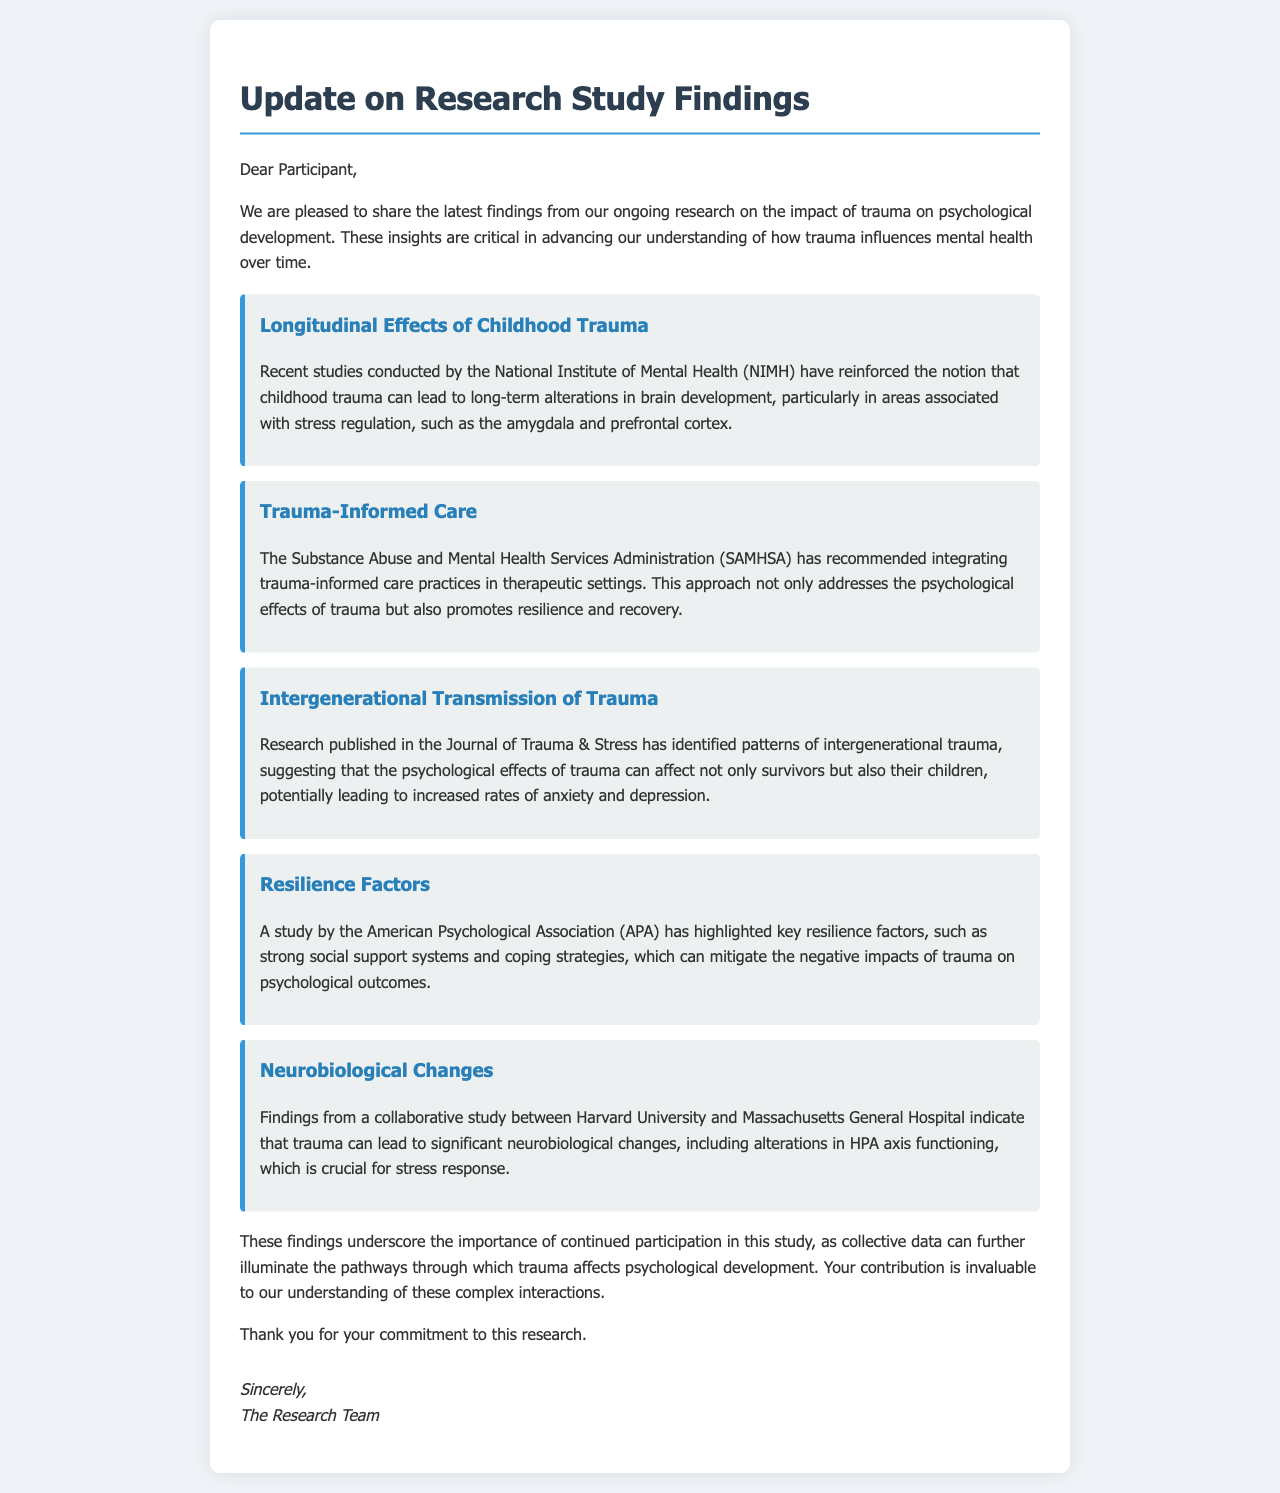What is the focus of the recent studies conducted by NIMH? The focus is on the long-term alterations in brain development due to childhood trauma.
Answer: Long-term alterations in brain development What organization recommends trauma-informed care practices? The document mentions a specific organization that supports this approach in therapeutic settings.
Answer: SAMHSA What can childhood trauma lead to according to intergenerational trauma research? The document states the potential outcomes for children of trauma survivors.
Answer: Increased rates of anxiety and depression What are two resilience factors highlighted by the APA study? This question asks for specific factors that help mitigate the impacts of trauma on psychological outcomes.
Answer: Strong social support systems and coping strategies Which two institutions collaborated on the research related to neurobiological changes? The document refers to two institutions involved in this collaborative study on trauma's effects.
Answer: Harvard University and Massachusetts General Hospital What is emphasized by the findings regarding continued participation in the study? This question aims to grasp the significance of participant involvement in further research understanding.
Answer: Importance of collective data What type of document is this update considered? This question identifies the nature or format of the content presented.
Answer: Letter 